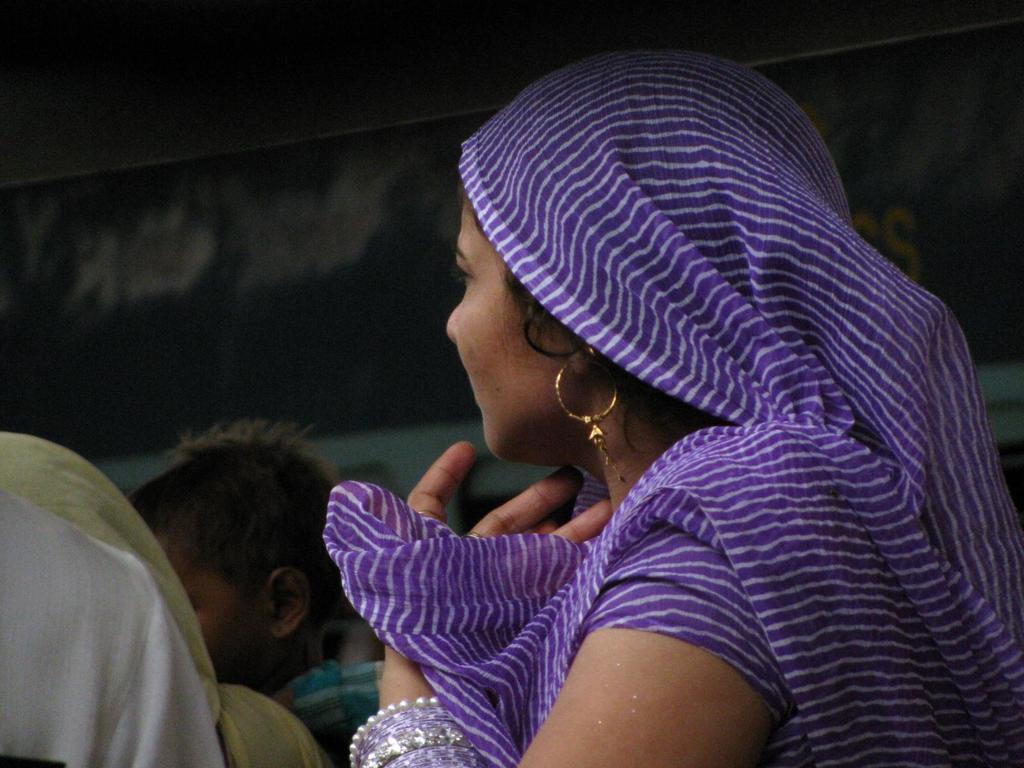Describe this image in one or two sentences. There is a woman wearing earring and bangles. In the back there's a lady and a child. In the background it is blurred. 